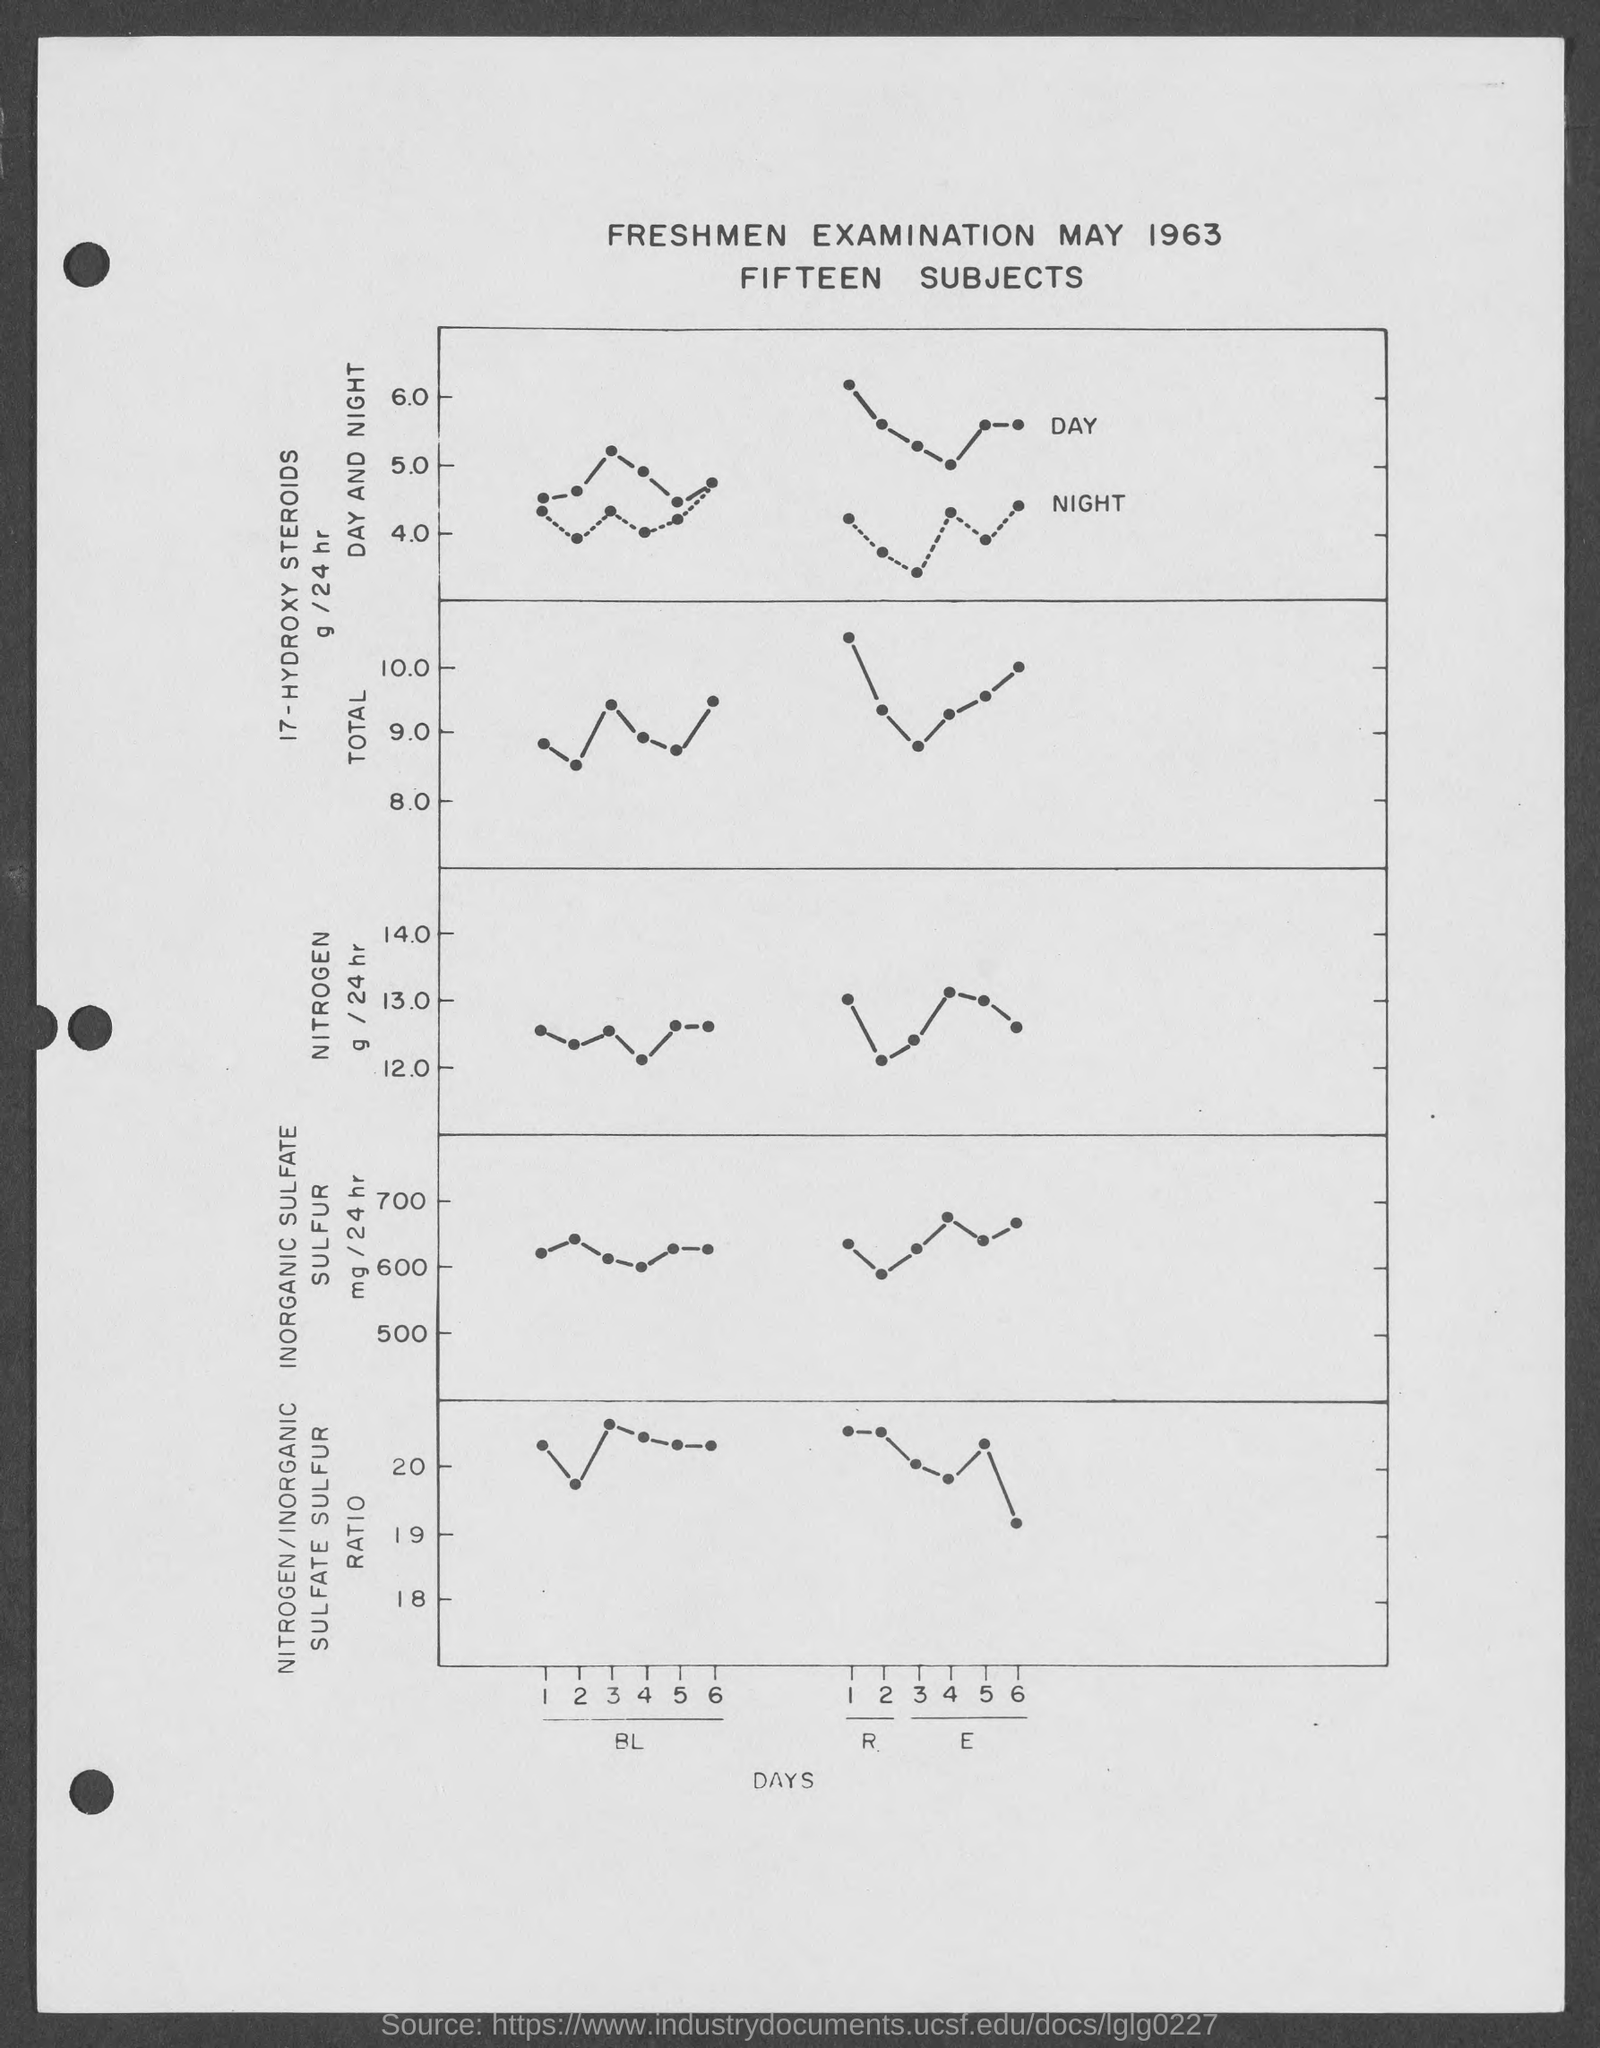Mention the heading of the plot?
Provide a succinct answer. FRESHMEN EXAMINATION MAY 1963. What is mentioned on the x-axis of the plot?
Keep it short and to the point. Days. How many "subjects"are mentioned in the heading?
Your answer should be compact. Fifteen. 